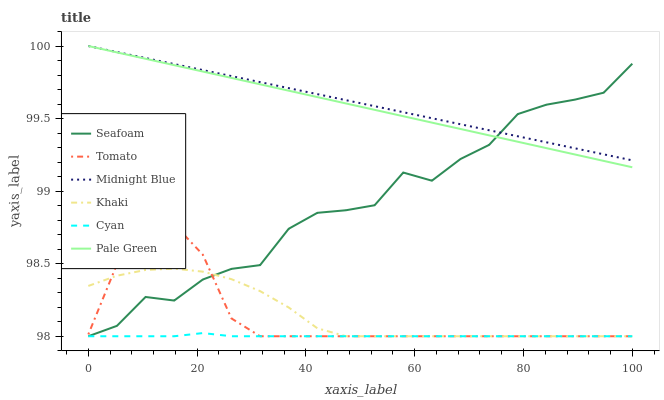Does Cyan have the minimum area under the curve?
Answer yes or no. Yes. Does Midnight Blue have the maximum area under the curve?
Answer yes or no. Yes. Does Khaki have the minimum area under the curve?
Answer yes or no. No. Does Khaki have the maximum area under the curve?
Answer yes or no. No. Is Pale Green the smoothest?
Answer yes or no. Yes. Is Seafoam the roughest?
Answer yes or no. Yes. Is Khaki the smoothest?
Answer yes or no. No. Is Khaki the roughest?
Answer yes or no. No. Does Tomato have the lowest value?
Answer yes or no. Yes. Does Midnight Blue have the lowest value?
Answer yes or no. No. Does Pale Green have the highest value?
Answer yes or no. Yes. Does Khaki have the highest value?
Answer yes or no. No. Is Khaki less than Midnight Blue?
Answer yes or no. Yes. Is Pale Green greater than Khaki?
Answer yes or no. Yes. Does Tomato intersect Seafoam?
Answer yes or no. Yes. Is Tomato less than Seafoam?
Answer yes or no. No. Is Tomato greater than Seafoam?
Answer yes or no. No. Does Khaki intersect Midnight Blue?
Answer yes or no. No. 